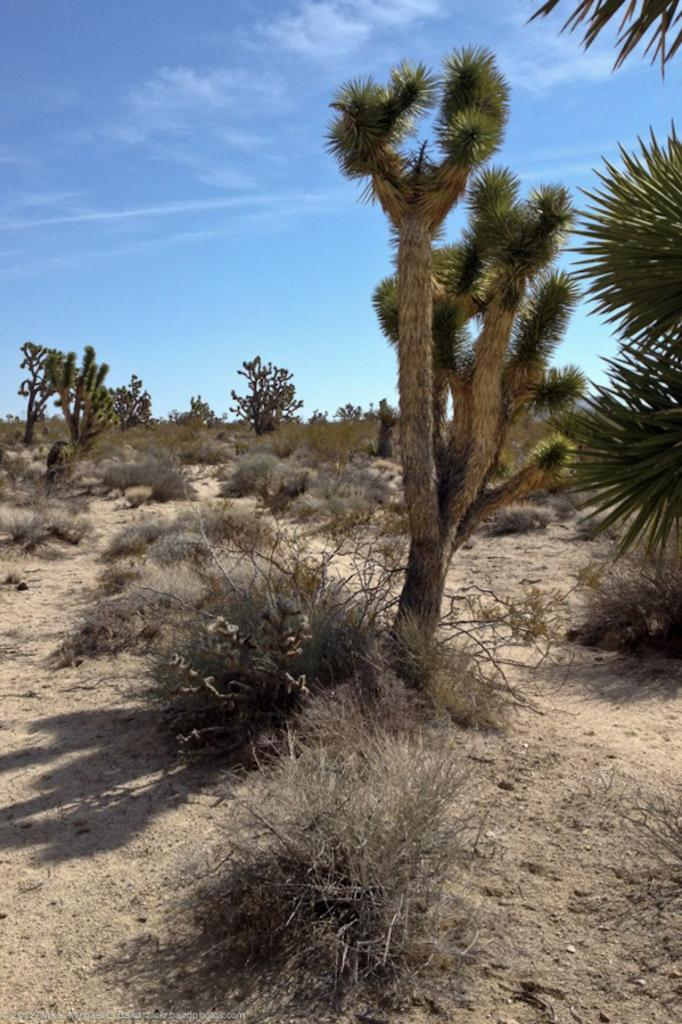What type of vegetation can be seen in the image? There are bushes and trees in the image. Are there any shadows visible in the image? Yes, shadows are visible in the image. What can be seen in the background of the image? Clouds and the sky are present in the background of the image. What type of punishment is being administered to the tank in the image? There is no tank present in the image, and therefore no punishment can be observed. Can you guide me to the location of the guide in the image? There is no guide present in the image, so it cannot be guided to a specific location. 